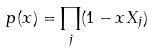Convert formula to latex. <formula><loc_0><loc_0><loc_500><loc_500>p ( x ) = \prod _ { j } ( 1 - x X _ { j } )</formula> 